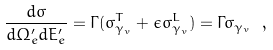<formula> <loc_0><loc_0><loc_500><loc_500>\frac { d \sigma } { d \Omega ^ { \prime } _ { e } d E ^ { \prime } _ { e } } = \Gamma ( \sigma _ { \gamma _ { v } } ^ { T } + \epsilon \sigma ^ { L } _ { \gamma _ { v } } ) = \Gamma \sigma _ { \gamma _ { v } } \ ,</formula> 